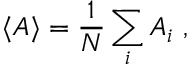<formula> <loc_0><loc_0><loc_500><loc_500>\langle A \rangle = \frac { 1 } { N } \sum _ { i } A _ { i } \ ,</formula> 